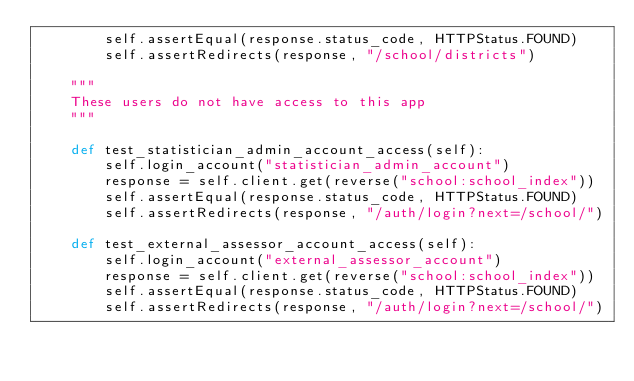Convert code to text. <code><loc_0><loc_0><loc_500><loc_500><_Python_>        self.assertEqual(response.status_code, HTTPStatus.FOUND)
        self.assertRedirects(response, "/school/districts")

    """
    These users do not have access to this app
    """

    def test_statistician_admin_account_access(self):
        self.login_account("statistician_admin_account")
        response = self.client.get(reverse("school:school_index"))
        self.assertEqual(response.status_code, HTTPStatus.FOUND)
        self.assertRedirects(response, "/auth/login?next=/school/")

    def test_external_assessor_account_access(self):
        self.login_account("external_assessor_account")
        response = self.client.get(reverse("school:school_index"))
        self.assertEqual(response.status_code, HTTPStatus.FOUND)
        self.assertRedirects(response, "/auth/login?next=/school/")
</code> 